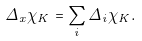<formula> <loc_0><loc_0><loc_500><loc_500>\Delta _ { x } \chi _ { K } = \sum _ { i } \Delta _ { i } \chi _ { K } .</formula> 